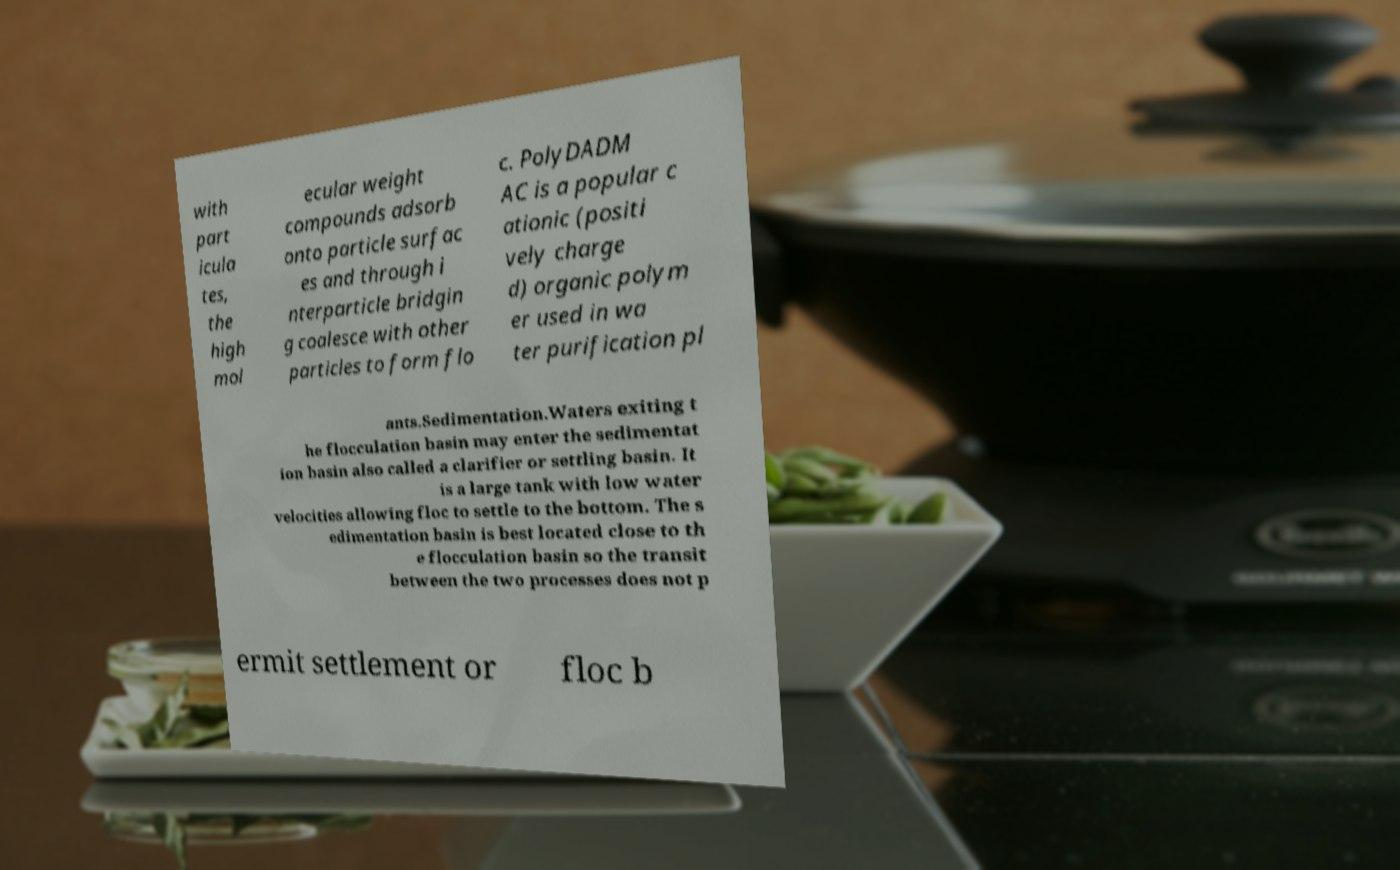Can you accurately transcribe the text from the provided image for me? with part icula tes, the high mol ecular weight compounds adsorb onto particle surfac es and through i nterparticle bridgin g coalesce with other particles to form flo c. PolyDADM AC is a popular c ationic (positi vely charge d) organic polym er used in wa ter purification pl ants.Sedimentation.Waters exiting t he flocculation basin may enter the sedimentat ion basin also called a clarifier or settling basin. It is a large tank with low water velocities allowing floc to settle to the bottom. The s edimentation basin is best located close to th e flocculation basin so the transit between the two processes does not p ermit settlement or floc b 